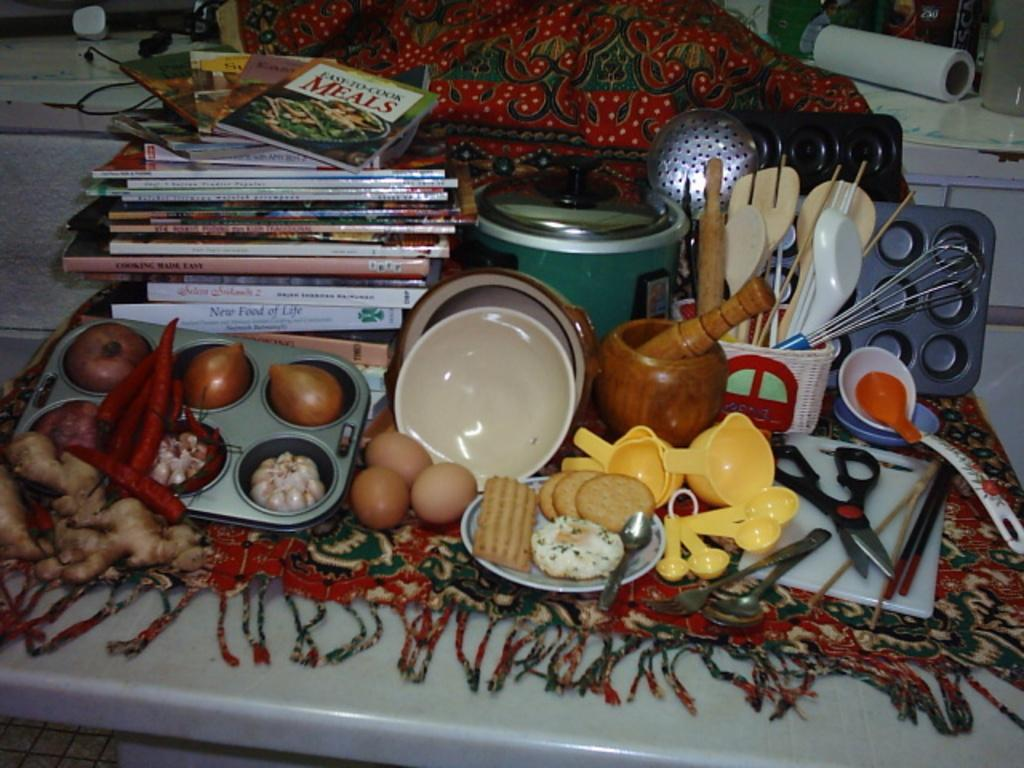<image>
Relay a brief, clear account of the picture shown. Table full of food including a book that says MEALS on it. 